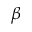<formula> <loc_0><loc_0><loc_500><loc_500>\beta</formula> 